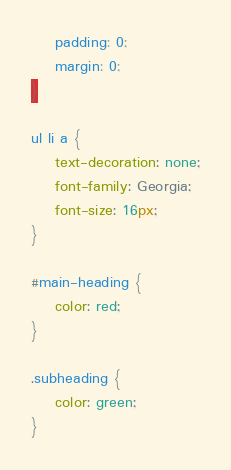Convert code to text. <code><loc_0><loc_0><loc_500><loc_500><_CSS_>	padding: 0;
	margin: 0;
}

ul li a {
	text-decoration: none;
	font-family: Georgia;
	font-size: 16px;
}

#main-heading {
	color: red;
}

.subheading {
	color: green;
}</code> 